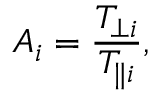<formula> <loc_0><loc_0><loc_500><loc_500>A _ { i } = \frac { T _ { \perp i } } { T _ { \| i } } ,</formula> 